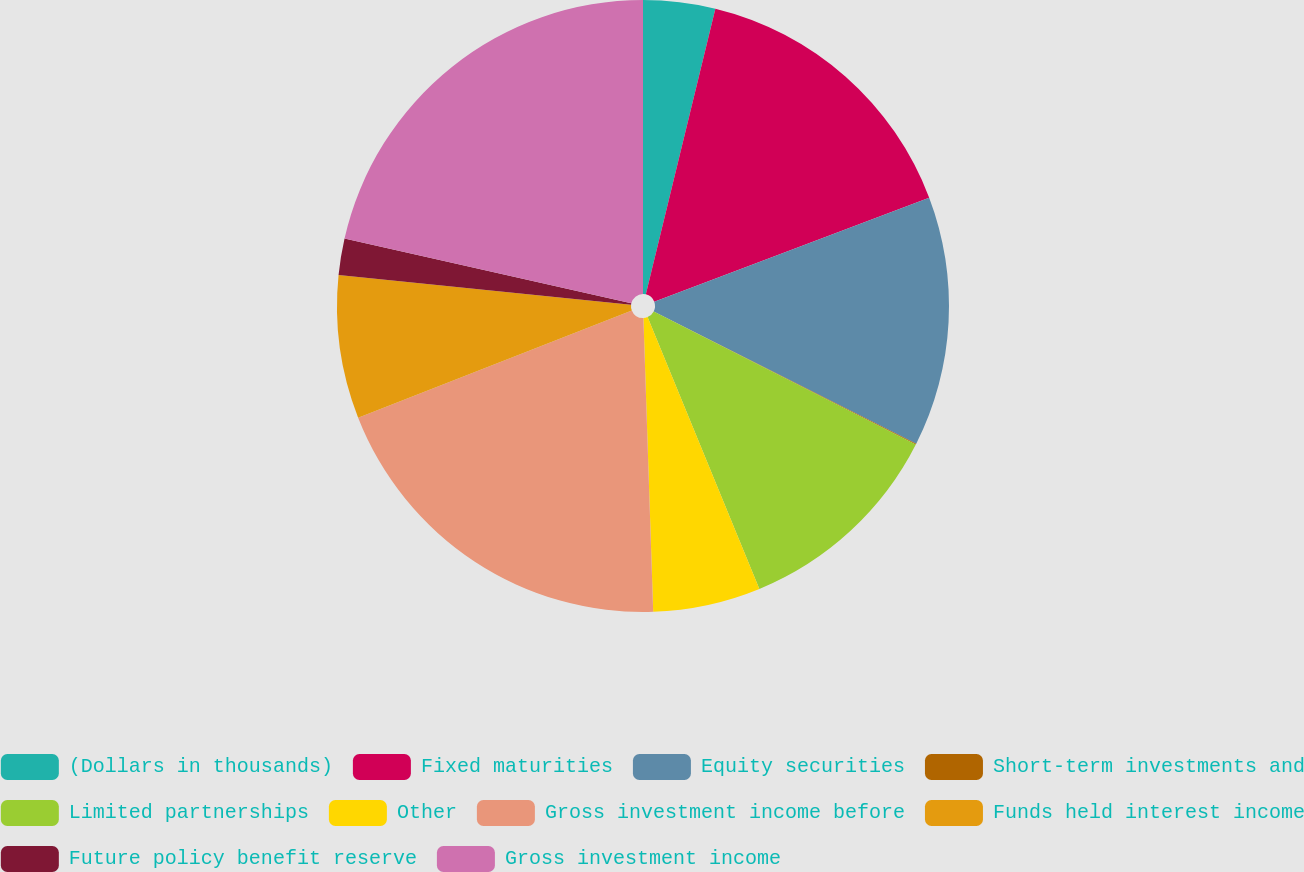<chart> <loc_0><loc_0><loc_500><loc_500><pie_chart><fcel>(Dollars in thousands)<fcel>Fixed maturities<fcel>Equity securities<fcel>Short-term investments and<fcel>Limited partnerships<fcel>Other<fcel>Gross investment income before<fcel>Funds held interest income<fcel>Future policy benefit reserve<fcel>Gross investment income<nl><fcel>3.8%<fcel>15.44%<fcel>13.19%<fcel>0.05%<fcel>11.31%<fcel>5.68%<fcel>19.58%<fcel>7.56%<fcel>1.93%<fcel>21.46%<nl></chart> 